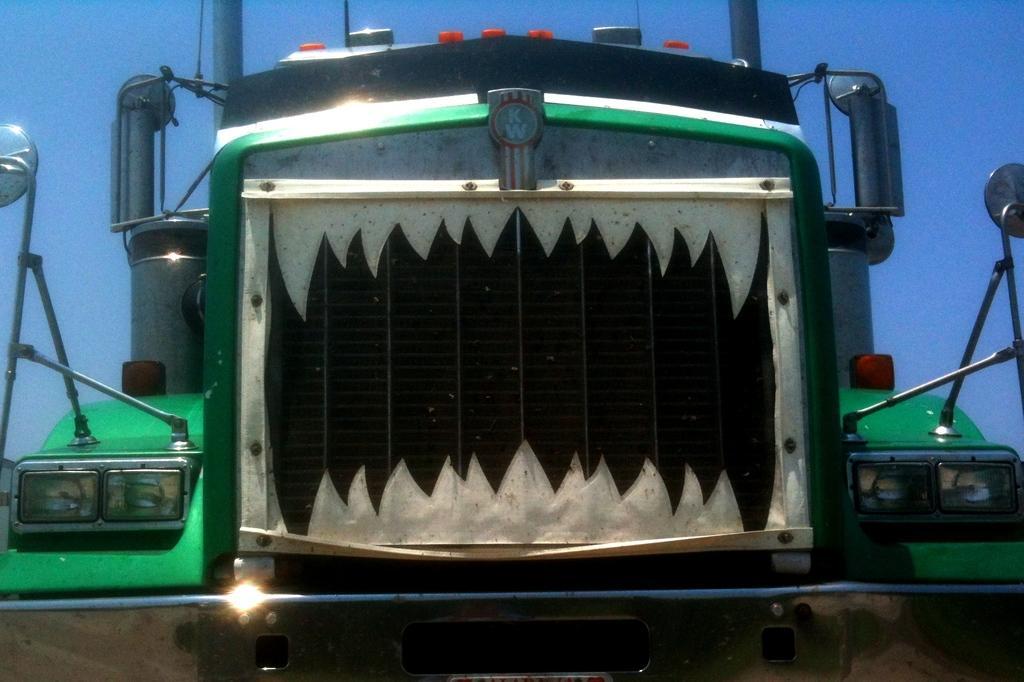Describe this image in one or two sentences. In the center of the image, we can see a vehicle. At the top, there is sky. 